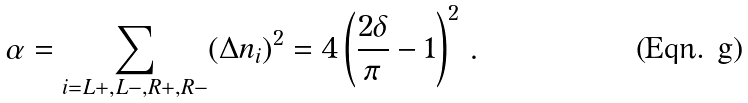<formula> <loc_0><loc_0><loc_500><loc_500>\alpha = \sum _ { i = L + , L - , R + , R - } ( \Delta n _ { i } ) ^ { 2 } = 4 \left ( \frac { 2 \delta } { \pi } - 1 \right ) ^ { 2 } \, .</formula> 